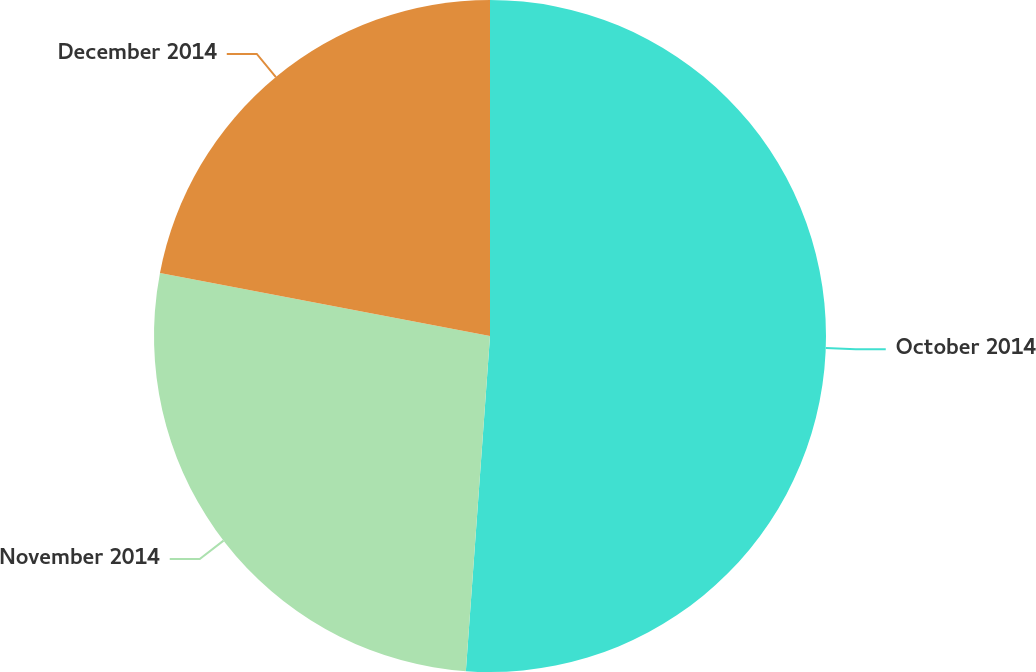<chart> <loc_0><loc_0><loc_500><loc_500><pie_chart><fcel>October 2014<fcel>November 2014<fcel>December 2014<nl><fcel>51.14%<fcel>26.86%<fcel>21.99%<nl></chart> 